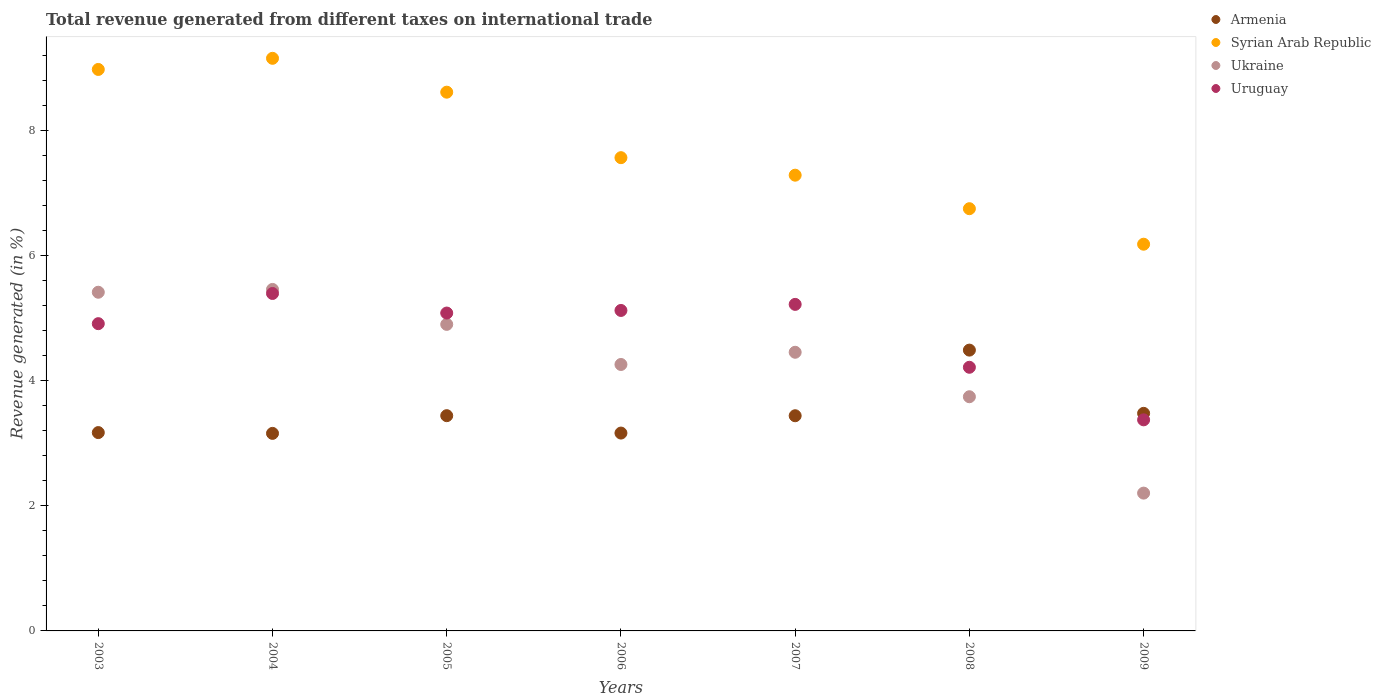How many different coloured dotlines are there?
Your answer should be very brief. 4. What is the total revenue generated in Armenia in 2008?
Your answer should be compact. 4.49. Across all years, what is the maximum total revenue generated in Uruguay?
Provide a short and direct response. 5.39. Across all years, what is the minimum total revenue generated in Syrian Arab Republic?
Ensure brevity in your answer.  6.18. What is the total total revenue generated in Ukraine in the graph?
Make the answer very short. 30.41. What is the difference between the total revenue generated in Armenia in 2003 and that in 2007?
Ensure brevity in your answer.  -0.27. What is the difference between the total revenue generated in Armenia in 2004 and the total revenue generated in Ukraine in 2009?
Keep it short and to the point. 0.95. What is the average total revenue generated in Ukraine per year?
Your response must be concise. 4.34. In the year 2003, what is the difference between the total revenue generated in Ukraine and total revenue generated in Syrian Arab Republic?
Provide a short and direct response. -3.56. In how many years, is the total revenue generated in Armenia greater than 4 %?
Provide a short and direct response. 1. What is the ratio of the total revenue generated in Ukraine in 2003 to that in 2006?
Provide a succinct answer. 1.27. What is the difference between the highest and the second highest total revenue generated in Ukraine?
Give a very brief answer. 0.04. What is the difference between the highest and the lowest total revenue generated in Ukraine?
Your response must be concise. 3.25. In how many years, is the total revenue generated in Syrian Arab Republic greater than the average total revenue generated in Syrian Arab Republic taken over all years?
Your response must be concise. 3. Is it the case that in every year, the sum of the total revenue generated in Uruguay and total revenue generated in Ukraine  is greater than the sum of total revenue generated in Syrian Arab Republic and total revenue generated in Armenia?
Give a very brief answer. No. How many years are there in the graph?
Give a very brief answer. 7. What is the difference between two consecutive major ticks on the Y-axis?
Ensure brevity in your answer.  2. Does the graph contain any zero values?
Offer a very short reply. No. How are the legend labels stacked?
Provide a short and direct response. Vertical. What is the title of the graph?
Your response must be concise. Total revenue generated from different taxes on international trade. What is the label or title of the Y-axis?
Keep it short and to the point. Revenue generated (in %). What is the Revenue generated (in %) in Armenia in 2003?
Offer a terse response. 3.17. What is the Revenue generated (in %) in Syrian Arab Republic in 2003?
Your answer should be very brief. 8.97. What is the Revenue generated (in %) in Ukraine in 2003?
Provide a succinct answer. 5.41. What is the Revenue generated (in %) of Uruguay in 2003?
Ensure brevity in your answer.  4.91. What is the Revenue generated (in %) of Armenia in 2004?
Make the answer very short. 3.16. What is the Revenue generated (in %) of Syrian Arab Republic in 2004?
Your answer should be very brief. 9.15. What is the Revenue generated (in %) in Ukraine in 2004?
Give a very brief answer. 5.46. What is the Revenue generated (in %) of Uruguay in 2004?
Ensure brevity in your answer.  5.39. What is the Revenue generated (in %) in Armenia in 2005?
Provide a succinct answer. 3.44. What is the Revenue generated (in %) of Syrian Arab Republic in 2005?
Keep it short and to the point. 8.61. What is the Revenue generated (in %) of Ukraine in 2005?
Make the answer very short. 4.9. What is the Revenue generated (in %) in Uruguay in 2005?
Make the answer very short. 5.08. What is the Revenue generated (in %) in Armenia in 2006?
Offer a terse response. 3.16. What is the Revenue generated (in %) of Syrian Arab Republic in 2006?
Your response must be concise. 7.56. What is the Revenue generated (in %) in Ukraine in 2006?
Give a very brief answer. 4.26. What is the Revenue generated (in %) of Uruguay in 2006?
Your answer should be compact. 5.12. What is the Revenue generated (in %) of Armenia in 2007?
Provide a short and direct response. 3.44. What is the Revenue generated (in %) in Syrian Arab Republic in 2007?
Offer a very short reply. 7.28. What is the Revenue generated (in %) of Ukraine in 2007?
Your answer should be compact. 4.45. What is the Revenue generated (in %) in Uruguay in 2007?
Your response must be concise. 5.22. What is the Revenue generated (in %) in Armenia in 2008?
Ensure brevity in your answer.  4.49. What is the Revenue generated (in %) of Syrian Arab Republic in 2008?
Offer a very short reply. 6.75. What is the Revenue generated (in %) of Ukraine in 2008?
Your answer should be very brief. 3.74. What is the Revenue generated (in %) of Uruguay in 2008?
Your answer should be compact. 4.21. What is the Revenue generated (in %) in Armenia in 2009?
Provide a short and direct response. 3.48. What is the Revenue generated (in %) in Syrian Arab Republic in 2009?
Ensure brevity in your answer.  6.18. What is the Revenue generated (in %) of Ukraine in 2009?
Keep it short and to the point. 2.2. What is the Revenue generated (in %) of Uruguay in 2009?
Your answer should be very brief. 3.37. Across all years, what is the maximum Revenue generated (in %) of Armenia?
Provide a short and direct response. 4.49. Across all years, what is the maximum Revenue generated (in %) of Syrian Arab Republic?
Ensure brevity in your answer.  9.15. Across all years, what is the maximum Revenue generated (in %) in Ukraine?
Keep it short and to the point. 5.46. Across all years, what is the maximum Revenue generated (in %) of Uruguay?
Provide a succinct answer. 5.39. Across all years, what is the minimum Revenue generated (in %) in Armenia?
Ensure brevity in your answer.  3.16. Across all years, what is the minimum Revenue generated (in %) of Syrian Arab Republic?
Give a very brief answer. 6.18. Across all years, what is the minimum Revenue generated (in %) in Ukraine?
Ensure brevity in your answer.  2.2. Across all years, what is the minimum Revenue generated (in %) in Uruguay?
Your answer should be very brief. 3.37. What is the total Revenue generated (in %) of Armenia in the graph?
Provide a succinct answer. 24.32. What is the total Revenue generated (in %) of Syrian Arab Republic in the graph?
Offer a terse response. 54.49. What is the total Revenue generated (in %) in Ukraine in the graph?
Provide a short and direct response. 30.41. What is the total Revenue generated (in %) of Uruguay in the graph?
Make the answer very short. 33.3. What is the difference between the Revenue generated (in %) of Armenia in 2003 and that in 2004?
Your response must be concise. 0.01. What is the difference between the Revenue generated (in %) in Syrian Arab Republic in 2003 and that in 2004?
Give a very brief answer. -0.18. What is the difference between the Revenue generated (in %) in Ukraine in 2003 and that in 2004?
Offer a very short reply. -0.04. What is the difference between the Revenue generated (in %) of Uruguay in 2003 and that in 2004?
Your answer should be compact. -0.48. What is the difference between the Revenue generated (in %) in Armenia in 2003 and that in 2005?
Your response must be concise. -0.27. What is the difference between the Revenue generated (in %) of Syrian Arab Republic in 2003 and that in 2005?
Your answer should be very brief. 0.36. What is the difference between the Revenue generated (in %) in Ukraine in 2003 and that in 2005?
Your answer should be compact. 0.51. What is the difference between the Revenue generated (in %) of Uruguay in 2003 and that in 2005?
Provide a succinct answer. -0.17. What is the difference between the Revenue generated (in %) of Armenia in 2003 and that in 2006?
Provide a short and direct response. 0.01. What is the difference between the Revenue generated (in %) in Syrian Arab Republic in 2003 and that in 2006?
Offer a very short reply. 1.41. What is the difference between the Revenue generated (in %) in Ukraine in 2003 and that in 2006?
Make the answer very short. 1.15. What is the difference between the Revenue generated (in %) of Uruguay in 2003 and that in 2006?
Ensure brevity in your answer.  -0.21. What is the difference between the Revenue generated (in %) in Armenia in 2003 and that in 2007?
Your answer should be very brief. -0.27. What is the difference between the Revenue generated (in %) in Syrian Arab Republic in 2003 and that in 2007?
Provide a succinct answer. 1.69. What is the difference between the Revenue generated (in %) in Uruguay in 2003 and that in 2007?
Your response must be concise. -0.31. What is the difference between the Revenue generated (in %) of Armenia in 2003 and that in 2008?
Give a very brief answer. -1.32. What is the difference between the Revenue generated (in %) of Syrian Arab Republic in 2003 and that in 2008?
Offer a terse response. 2.22. What is the difference between the Revenue generated (in %) of Ukraine in 2003 and that in 2008?
Ensure brevity in your answer.  1.67. What is the difference between the Revenue generated (in %) in Uruguay in 2003 and that in 2008?
Provide a succinct answer. 0.7. What is the difference between the Revenue generated (in %) in Armenia in 2003 and that in 2009?
Offer a terse response. -0.31. What is the difference between the Revenue generated (in %) of Syrian Arab Republic in 2003 and that in 2009?
Provide a short and direct response. 2.79. What is the difference between the Revenue generated (in %) of Ukraine in 2003 and that in 2009?
Your answer should be very brief. 3.21. What is the difference between the Revenue generated (in %) of Uruguay in 2003 and that in 2009?
Give a very brief answer. 1.54. What is the difference between the Revenue generated (in %) in Armenia in 2004 and that in 2005?
Your response must be concise. -0.28. What is the difference between the Revenue generated (in %) in Syrian Arab Republic in 2004 and that in 2005?
Your answer should be compact. 0.54. What is the difference between the Revenue generated (in %) in Ukraine in 2004 and that in 2005?
Offer a very short reply. 0.56. What is the difference between the Revenue generated (in %) in Uruguay in 2004 and that in 2005?
Provide a succinct answer. 0.31. What is the difference between the Revenue generated (in %) in Armenia in 2004 and that in 2006?
Your response must be concise. -0.01. What is the difference between the Revenue generated (in %) in Syrian Arab Republic in 2004 and that in 2006?
Offer a very short reply. 1.59. What is the difference between the Revenue generated (in %) in Ukraine in 2004 and that in 2006?
Keep it short and to the point. 1.2. What is the difference between the Revenue generated (in %) of Uruguay in 2004 and that in 2006?
Keep it short and to the point. 0.27. What is the difference between the Revenue generated (in %) of Armenia in 2004 and that in 2007?
Make the answer very short. -0.28. What is the difference between the Revenue generated (in %) in Syrian Arab Republic in 2004 and that in 2007?
Keep it short and to the point. 1.87. What is the difference between the Revenue generated (in %) in Uruguay in 2004 and that in 2007?
Give a very brief answer. 0.17. What is the difference between the Revenue generated (in %) in Armenia in 2004 and that in 2008?
Keep it short and to the point. -1.33. What is the difference between the Revenue generated (in %) in Syrian Arab Republic in 2004 and that in 2008?
Your answer should be very brief. 2.4. What is the difference between the Revenue generated (in %) in Ukraine in 2004 and that in 2008?
Your answer should be compact. 1.71. What is the difference between the Revenue generated (in %) of Uruguay in 2004 and that in 2008?
Your answer should be very brief. 1.18. What is the difference between the Revenue generated (in %) in Armenia in 2004 and that in 2009?
Give a very brief answer. -0.32. What is the difference between the Revenue generated (in %) in Syrian Arab Republic in 2004 and that in 2009?
Your answer should be compact. 2.97. What is the difference between the Revenue generated (in %) of Ukraine in 2004 and that in 2009?
Your response must be concise. 3.25. What is the difference between the Revenue generated (in %) of Uruguay in 2004 and that in 2009?
Make the answer very short. 2.02. What is the difference between the Revenue generated (in %) of Armenia in 2005 and that in 2006?
Your answer should be compact. 0.28. What is the difference between the Revenue generated (in %) in Syrian Arab Republic in 2005 and that in 2006?
Make the answer very short. 1.05. What is the difference between the Revenue generated (in %) of Ukraine in 2005 and that in 2006?
Provide a succinct answer. 0.64. What is the difference between the Revenue generated (in %) of Uruguay in 2005 and that in 2006?
Offer a very short reply. -0.04. What is the difference between the Revenue generated (in %) in Armenia in 2005 and that in 2007?
Offer a very short reply. 0. What is the difference between the Revenue generated (in %) in Syrian Arab Republic in 2005 and that in 2007?
Provide a succinct answer. 1.33. What is the difference between the Revenue generated (in %) in Ukraine in 2005 and that in 2007?
Provide a succinct answer. 0.45. What is the difference between the Revenue generated (in %) of Uruguay in 2005 and that in 2007?
Make the answer very short. -0.14. What is the difference between the Revenue generated (in %) in Armenia in 2005 and that in 2008?
Offer a very short reply. -1.05. What is the difference between the Revenue generated (in %) of Syrian Arab Republic in 2005 and that in 2008?
Your response must be concise. 1.86. What is the difference between the Revenue generated (in %) of Ukraine in 2005 and that in 2008?
Give a very brief answer. 1.16. What is the difference between the Revenue generated (in %) in Uruguay in 2005 and that in 2008?
Your answer should be compact. 0.87. What is the difference between the Revenue generated (in %) of Armenia in 2005 and that in 2009?
Give a very brief answer. -0.04. What is the difference between the Revenue generated (in %) in Syrian Arab Republic in 2005 and that in 2009?
Keep it short and to the point. 2.43. What is the difference between the Revenue generated (in %) of Ukraine in 2005 and that in 2009?
Ensure brevity in your answer.  2.7. What is the difference between the Revenue generated (in %) of Uruguay in 2005 and that in 2009?
Give a very brief answer. 1.71. What is the difference between the Revenue generated (in %) of Armenia in 2006 and that in 2007?
Your answer should be compact. -0.28. What is the difference between the Revenue generated (in %) in Syrian Arab Republic in 2006 and that in 2007?
Ensure brevity in your answer.  0.28. What is the difference between the Revenue generated (in %) of Ukraine in 2006 and that in 2007?
Provide a short and direct response. -0.2. What is the difference between the Revenue generated (in %) in Uruguay in 2006 and that in 2007?
Make the answer very short. -0.1. What is the difference between the Revenue generated (in %) in Armenia in 2006 and that in 2008?
Your answer should be compact. -1.33. What is the difference between the Revenue generated (in %) in Syrian Arab Republic in 2006 and that in 2008?
Provide a short and direct response. 0.82. What is the difference between the Revenue generated (in %) in Ukraine in 2006 and that in 2008?
Offer a very short reply. 0.52. What is the difference between the Revenue generated (in %) of Uruguay in 2006 and that in 2008?
Your answer should be very brief. 0.91. What is the difference between the Revenue generated (in %) in Armenia in 2006 and that in 2009?
Offer a terse response. -0.32. What is the difference between the Revenue generated (in %) in Syrian Arab Republic in 2006 and that in 2009?
Keep it short and to the point. 1.38. What is the difference between the Revenue generated (in %) in Ukraine in 2006 and that in 2009?
Give a very brief answer. 2.06. What is the difference between the Revenue generated (in %) of Uruguay in 2006 and that in 2009?
Ensure brevity in your answer.  1.75. What is the difference between the Revenue generated (in %) in Armenia in 2007 and that in 2008?
Your response must be concise. -1.05. What is the difference between the Revenue generated (in %) of Syrian Arab Republic in 2007 and that in 2008?
Your answer should be compact. 0.54. What is the difference between the Revenue generated (in %) in Ukraine in 2007 and that in 2008?
Your response must be concise. 0.71. What is the difference between the Revenue generated (in %) in Uruguay in 2007 and that in 2008?
Your answer should be compact. 1. What is the difference between the Revenue generated (in %) of Armenia in 2007 and that in 2009?
Keep it short and to the point. -0.04. What is the difference between the Revenue generated (in %) in Syrian Arab Republic in 2007 and that in 2009?
Give a very brief answer. 1.1. What is the difference between the Revenue generated (in %) in Ukraine in 2007 and that in 2009?
Offer a terse response. 2.25. What is the difference between the Revenue generated (in %) in Uruguay in 2007 and that in 2009?
Ensure brevity in your answer.  1.84. What is the difference between the Revenue generated (in %) in Armenia in 2008 and that in 2009?
Ensure brevity in your answer.  1.01. What is the difference between the Revenue generated (in %) in Syrian Arab Republic in 2008 and that in 2009?
Provide a short and direct response. 0.57. What is the difference between the Revenue generated (in %) in Ukraine in 2008 and that in 2009?
Your response must be concise. 1.54. What is the difference between the Revenue generated (in %) of Uruguay in 2008 and that in 2009?
Offer a very short reply. 0.84. What is the difference between the Revenue generated (in %) of Armenia in 2003 and the Revenue generated (in %) of Syrian Arab Republic in 2004?
Provide a succinct answer. -5.98. What is the difference between the Revenue generated (in %) of Armenia in 2003 and the Revenue generated (in %) of Ukraine in 2004?
Give a very brief answer. -2.29. What is the difference between the Revenue generated (in %) of Armenia in 2003 and the Revenue generated (in %) of Uruguay in 2004?
Make the answer very short. -2.22. What is the difference between the Revenue generated (in %) in Syrian Arab Republic in 2003 and the Revenue generated (in %) in Ukraine in 2004?
Offer a very short reply. 3.51. What is the difference between the Revenue generated (in %) of Syrian Arab Republic in 2003 and the Revenue generated (in %) of Uruguay in 2004?
Your response must be concise. 3.58. What is the difference between the Revenue generated (in %) of Ukraine in 2003 and the Revenue generated (in %) of Uruguay in 2004?
Your response must be concise. 0.02. What is the difference between the Revenue generated (in %) in Armenia in 2003 and the Revenue generated (in %) in Syrian Arab Republic in 2005?
Provide a short and direct response. -5.44. What is the difference between the Revenue generated (in %) of Armenia in 2003 and the Revenue generated (in %) of Ukraine in 2005?
Ensure brevity in your answer.  -1.73. What is the difference between the Revenue generated (in %) in Armenia in 2003 and the Revenue generated (in %) in Uruguay in 2005?
Offer a very short reply. -1.91. What is the difference between the Revenue generated (in %) of Syrian Arab Republic in 2003 and the Revenue generated (in %) of Ukraine in 2005?
Ensure brevity in your answer.  4.07. What is the difference between the Revenue generated (in %) of Syrian Arab Republic in 2003 and the Revenue generated (in %) of Uruguay in 2005?
Offer a very short reply. 3.89. What is the difference between the Revenue generated (in %) in Ukraine in 2003 and the Revenue generated (in %) in Uruguay in 2005?
Ensure brevity in your answer.  0.33. What is the difference between the Revenue generated (in %) of Armenia in 2003 and the Revenue generated (in %) of Syrian Arab Republic in 2006?
Provide a succinct answer. -4.39. What is the difference between the Revenue generated (in %) in Armenia in 2003 and the Revenue generated (in %) in Ukraine in 2006?
Ensure brevity in your answer.  -1.09. What is the difference between the Revenue generated (in %) in Armenia in 2003 and the Revenue generated (in %) in Uruguay in 2006?
Offer a very short reply. -1.95. What is the difference between the Revenue generated (in %) in Syrian Arab Republic in 2003 and the Revenue generated (in %) in Ukraine in 2006?
Make the answer very short. 4.71. What is the difference between the Revenue generated (in %) in Syrian Arab Republic in 2003 and the Revenue generated (in %) in Uruguay in 2006?
Make the answer very short. 3.85. What is the difference between the Revenue generated (in %) in Ukraine in 2003 and the Revenue generated (in %) in Uruguay in 2006?
Your answer should be compact. 0.29. What is the difference between the Revenue generated (in %) in Armenia in 2003 and the Revenue generated (in %) in Syrian Arab Republic in 2007?
Keep it short and to the point. -4.11. What is the difference between the Revenue generated (in %) in Armenia in 2003 and the Revenue generated (in %) in Ukraine in 2007?
Your response must be concise. -1.28. What is the difference between the Revenue generated (in %) in Armenia in 2003 and the Revenue generated (in %) in Uruguay in 2007?
Make the answer very short. -2.05. What is the difference between the Revenue generated (in %) in Syrian Arab Republic in 2003 and the Revenue generated (in %) in Ukraine in 2007?
Offer a very short reply. 4.52. What is the difference between the Revenue generated (in %) in Syrian Arab Republic in 2003 and the Revenue generated (in %) in Uruguay in 2007?
Offer a terse response. 3.75. What is the difference between the Revenue generated (in %) in Ukraine in 2003 and the Revenue generated (in %) in Uruguay in 2007?
Offer a terse response. 0.19. What is the difference between the Revenue generated (in %) in Armenia in 2003 and the Revenue generated (in %) in Syrian Arab Republic in 2008?
Make the answer very short. -3.58. What is the difference between the Revenue generated (in %) of Armenia in 2003 and the Revenue generated (in %) of Ukraine in 2008?
Ensure brevity in your answer.  -0.57. What is the difference between the Revenue generated (in %) in Armenia in 2003 and the Revenue generated (in %) in Uruguay in 2008?
Ensure brevity in your answer.  -1.04. What is the difference between the Revenue generated (in %) of Syrian Arab Republic in 2003 and the Revenue generated (in %) of Ukraine in 2008?
Your response must be concise. 5.23. What is the difference between the Revenue generated (in %) of Syrian Arab Republic in 2003 and the Revenue generated (in %) of Uruguay in 2008?
Offer a terse response. 4.76. What is the difference between the Revenue generated (in %) of Ukraine in 2003 and the Revenue generated (in %) of Uruguay in 2008?
Provide a short and direct response. 1.2. What is the difference between the Revenue generated (in %) in Armenia in 2003 and the Revenue generated (in %) in Syrian Arab Republic in 2009?
Give a very brief answer. -3.01. What is the difference between the Revenue generated (in %) in Armenia in 2003 and the Revenue generated (in %) in Uruguay in 2009?
Ensure brevity in your answer.  -0.2. What is the difference between the Revenue generated (in %) in Syrian Arab Republic in 2003 and the Revenue generated (in %) in Ukraine in 2009?
Your response must be concise. 6.77. What is the difference between the Revenue generated (in %) in Syrian Arab Republic in 2003 and the Revenue generated (in %) in Uruguay in 2009?
Ensure brevity in your answer.  5.6. What is the difference between the Revenue generated (in %) in Ukraine in 2003 and the Revenue generated (in %) in Uruguay in 2009?
Make the answer very short. 2.04. What is the difference between the Revenue generated (in %) of Armenia in 2004 and the Revenue generated (in %) of Syrian Arab Republic in 2005?
Your response must be concise. -5.45. What is the difference between the Revenue generated (in %) in Armenia in 2004 and the Revenue generated (in %) in Ukraine in 2005?
Make the answer very short. -1.74. What is the difference between the Revenue generated (in %) in Armenia in 2004 and the Revenue generated (in %) in Uruguay in 2005?
Ensure brevity in your answer.  -1.92. What is the difference between the Revenue generated (in %) in Syrian Arab Republic in 2004 and the Revenue generated (in %) in Ukraine in 2005?
Provide a short and direct response. 4.25. What is the difference between the Revenue generated (in %) in Syrian Arab Republic in 2004 and the Revenue generated (in %) in Uruguay in 2005?
Your answer should be very brief. 4.07. What is the difference between the Revenue generated (in %) in Ukraine in 2004 and the Revenue generated (in %) in Uruguay in 2005?
Make the answer very short. 0.38. What is the difference between the Revenue generated (in %) of Armenia in 2004 and the Revenue generated (in %) of Syrian Arab Republic in 2006?
Your answer should be very brief. -4.4. What is the difference between the Revenue generated (in %) in Armenia in 2004 and the Revenue generated (in %) in Ukraine in 2006?
Offer a terse response. -1.1. What is the difference between the Revenue generated (in %) in Armenia in 2004 and the Revenue generated (in %) in Uruguay in 2006?
Provide a succinct answer. -1.96. What is the difference between the Revenue generated (in %) of Syrian Arab Republic in 2004 and the Revenue generated (in %) of Ukraine in 2006?
Your answer should be compact. 4.89. What is the difference between the Revenue generated (in %) in Syrian Arab Republic in 2004 and the Revenue generated (in %) in Uruguay in 2006?
Your answer should be compact. 4.03. What is the difference between the Revenue generated (in %) of Ukraine in 2004 and the Revenue generated (in %) of Uruguay in 2006?
Your answer should be compact. 0.34. What is the difference between the Revenue generated (in %) in Armenia in 2004 and the Revenue generated (in %) in Syrian Arab Republic in 2007?
Provide a short and direct response. -4.12. What is the difference between the Revenue generated (in %) of Armenia in 2004 and the Revenue generated (in %) of Ukraine in 2007?
Provide a succinct answer. -1.3. What is the difference between the Revenue generated (in %) of Armenia in 2004 and the Revenue generated (in %) of Uruguay in 2007?
Provide a short and direct response. -2.06. What is the difference between the Revenue generated (in %) in Syrian Arab Republic in 2004 and the Revenue generated (in %) in Ukraine in 2007?
Make the answer very short. 4.7. What is the difference between the Revenue generated (in %) in Syrian Arab Republic in 2004 and the Revenue generated (in %) in Uruguay in 2007?
Provide a short and direct response. 3.93. What is the difference between the Revenue generated (in %) of Ukraine in 2004 and the Revenue generated (in %) of Uruguay in 2007?
Make the answer very short. 0.24. What is the difference between the Revenue generated (in %) in Armenia in 2004 and the Revenue generated (in %) in Syrian Arab Republic in 2008?
Provide a succinct answer. -3.59. What is the difference between the Revenue generated (in %) of Armenia in 2004 and the Revenue generated (in %) of Ukraine in 2008?
Offer a terse response. -0.59. What is the difference between the Revenue generated (in %) of Armenia in 2004 and the Revenue generated (in %) of Uruguay in 2008?
Provide a short and direct response. -1.06. What is the difference between the Revenue generated (in %) in Syrian Arab Republic in 2004 and the Revenue generated (in %) in Ukraine in 2008?
Provide a succinct answer. 5.41. What is the difference between the Revenue generated (in %) in Syrian Arab Republic in 2004 and the Revenue generated (in %) in Uruguay in 2008?
Ensure brevity in your answer.  4.94. What is the difference between the Revenue generated (in %) of Ukraine in 2004 and the Revenue generated (in %) of Uruguay in 2008?
Ensure brevity in your answer.  1.24. What is the difference between the Revenue generated (in %) in Armenia in 2004 and the Revenue generated (in %) in Syrian Arab Republic in 2009?
Provide a short and direct response. -3.02. What is the difference between the Revenue generated (in %) in Armenia in 2004 and the Revenue generated (in %) in Ukraine in 2009?
Make the answer very short. 0.95. What is the difference between the Revenue generated (in %) in Armenia in 2004 and the Revenue generated (in %) in Uruguay in 2009?
Offer a very short reply. -0.22. What is the difference between the Revenue generated (in %) in Syrian Arab Republic in 2004 and the Revenue generated (in %) in Ukraine in 2009?
Provide a succinct answer. 6.95. What is the difference between the Revenue generated (in %) of Syrian Arab Republic in 2004 and the Revenue generated (in %) of Uruguay in 2009?
Make the answer very short. 5.78. What is the difference between the Revenue generated (in %) in Ukraine in 2004 and the Revenue generated (in %) in Uruguay in 2009?
Your answer should be compact. 2.08. What is the difference between the Revenue generated (in %) of Armenia in 2005 and the Revenue generated (in %) of Syrian Arab Republic in 2006?
Offer a terse response. -4.12. What is the difference between the Revenue generated (in %) of Armenia in 2005 and the Revenue generated (in %) of Ukraine in 2006?
Make the answer very short. -0.82. What is the difference between the Revenue generated (in %) in Armenia in 2005 and the Revenue generated (in %) in Uruguay in 2006?
Offer a very short reply. -1.68. What is the difference between the Revenue generated (in %) of Syrian Arab Republic in 2005 and the Revenue generated (in %) of Ukraine in 2006?
Your answer should be compact. 4.35. What is the difference between the Revenue generated (in %) of Syrian Arab Republic in 2005 and the Revenue generated (in %) of Uruguay in 2006?
Provide a succinct answer. 3.49. What is the difference between the Revenue generated (in %) in Ukraine in 2005 and the Revenue generated (in %) in Uruguay in 2006?
Offer a terse response. -0.22. What is the difference between the Revenue generated (in %) in Armenia in 2005 and the Revenue generated (in %) in Syrian Arab Republic in 2007?
Keep it short and to the point. -3.84. What is the difference between the Revenue generated (in %) in Armenia in 2005 and the Revenue generated (in %) in Ukraine in 2007?
Offer a very short reply. -1.01. What is the difference between the Revenue generated (in %) of Armenia in 2005 and the Revenue generated (in %) of Uruguay in 2007?
Give a very brief answer. -1.78. What is the difference between the Revenue generated (in %) in Syrian Arab Republic in 2005 and the Revenue generated (in %) in Ukraine in 2007?
Provide a succinct answer. 4.15. What is the difference between the Revenue generated (in %) of Syrian Arab Republic in 2005 and the Revenue generated (in %) of Uruguay in 2007?
Give a very brief answer. 3.39. What is the difference between the Revenue generated (in %) in Ukraine in 2005 and the Revenue generated (in %) in Uruguay in 2007?
Your answer should be very brief. -0.32. What is the difference between the Revenue generated (in %) of Armenia in 2005 and the Revenue generated (in %) of Syrian Arab Republic in 2008?
Keep it short and to the point. -3.31. What is the difference between the Revenue generated (in %) of Armenia in 2005 and the Revenue generated (in %) of Ukraine in 2008?
Ensure brevity in your answer.  -0.3. What is the difference between the Revenue generated (in %) in Armenia in 2005 and the Revenue generated (in %) in Uruguay in 2008?
Your answer should be very brief. -0.77. What is the difference between the Revenue generated (in %) in Syrian Arab Republic in 2005 and the Revenue generated (in %) in Ukraine in 2008?
Your answer should be very brief. 4.87. What is the difference between the Revenue generated (in %) of Syrian Arab Republic in 2005 and the Revenue generated (in %) of Uruguay in 2008?
Ensure brevity in your answer.  4.39. What is the difference between the Revenue generated (in %) of Ukraine in 2005 and the Revenue generated (in %) of Uruguay in 2008?
Ensure brevity in your answer.  0.69. What is the difference between the Revenue generated (in %) in Armenia in 2005 and the Revenue generated (in %) in Syrian Arab Republic in 2009?
Your answer should be compact. -2.74. What is the difference between the Revenue generated (in %) in Armenia in 2005 and the Revenue generated (in %) in Ukraine in 2009?
Offer a very short reply. 1.24. What is the difference between the Revenue generated (in %) of Armenia in 2005 and the Revenue generated (in %) of Uruguay in 2009?
Offer a terse response. 0.07. What is the difference between the Revenue generated (in %) of Syrian Arab Republic in 2005 and the Revenue generated (in %) of Ukraine in 2009?
Your response must be concise. 6.41. What is the difference between the Revenue generated (in %) of Syrian Arab Republic in 2005 and the Revenue generated (in %) of Uruguay in 2009?
Provide a succinct answer. 5.23. What is the difference between the Revenue generated (in %) of Ukraine in 2005 and the Revenue generated (in %) of Uruguay in 2009?
Provide a succinct answer. 1.53. What is the difference between the Revenue generated (in %) in Armenia in 2006 and the Revenue generated (in %) in Syrian Arab Republic in 2007?
Your response must be concise. -4.12. What is the difference between the Revenue generated (in %) of Armenia in 2006 and the Revenue generated (in %) of Ukraine in 2007?
Keep it short and to the point. -1.29. What is the difference between the Revenue generated (in %) of Armenia in 2006 and the Revenue generated (in %) of Uruguay in 2007?
Offer a terse response. -2.06. What is the difference between the Revenue generated (in %) in Syrian Arab Republic in 2006 and the Revenue generated (in %) in Ukraine in 2007?
Offer a terse response. 3.11. What is the difference between the Revenue generated (in %) in Syrian Arab Republic in 2006 and the Revenue generated (in %) in Uruguay in 2007?
Give a very brief answer. 2.34. What is the difference between the Revenue generated (in %) of Ukraine in 2006 and the Revenue generated (in %) of Uruguay in 2007?
Give a very brief answer. -0.96. What is the difference between the Revenue generated (in %) of Armenia in 2006 and the Revenue generated (in %) of Syrian Arab Republic in 2008?
Provide a succinct answer. -3.58. What is the difference between the Revenue generated (in %) in Armenia in 2006 and the Revenue generated (in %) in Ukraine in 2008?
Keep it short and to the point. -0.58. What is the difference between the Revenue generated (in %) in Armenia in 2006 and the Revenue generated (in %) in Uruguay in 2008?
Your answer should be very brief. -1.05. What is the difference between the Revenue generated (in %) in Syrian Arab Republic in 2006 and the Revenue generated (in %) in Ukraine in 2008?
Make the answer very short. 3.82. What is the difference between the Revenue generated (in %) of Syrian Arab Republic in 2006 and the Revenue generated (in %) of Uruguay in 2008?
Your response must be concise. 3.35. What is the difference between the Revenue generated (in %) in Ukraine in 2006 and the Revenue generated (in %) in Uruguay in 2008?
Make the answer very short. 0.04. What is the difference between the Revenue generated (in %) of Armenia in 2006 and the Revenue generated (in %) of Syrian Arab Republic in 2009?
Offer a very short reply. -3.02. What is the difference between the Revenue generated (in %) in Armenia in 2006 and the Revenue generated (in %) in Ukraine in 2009?
Make the answer very short. 0.96. What is the difference between the Revenue generated (in %) in Armenia in 2006 and the Revenue generated (in %) in Uruguay in 2009?
Offer a terse response. -0.21. What is the difference between the Revenue generated (in %) in Syrian Arab Republic in 2006 and the Revenue generated (in %) in Ukraine in 2009?
Offer a very short reply. 5.36. What is the difference between the Revenue generated (in %) of Syrian Arab Republic in 2006 and the Revenue generated (in %) of Uruguay in 2009?
Provide a short and direct response. 4.19. What is the difference between the Revenue generated (in %) of Ukraine in 2006 and the Revenue generated (in %) of Uruguay in 2009?
Offer a very short reply. 0.88. What is the difference between the Revenue generated (in %) in Armenia in 2007 and the Revenue generated (in %) in Syrian Arab Republic in 2008?
Make the answer very short. -3.31. What is the difference between the Revenue generated (in %) in Armenia in 2007 and the Revenue generated (in %) in Ukraine in 2008?
Provide a succinct answer. -0.3. What is the difference between the Revenue generated (in %) in Armenia in 2007 and the Revenue generated (in %) in Uruguay in 2008?
Offer a terse response. -0.77. What is the difference between the Revenue generated (in %) in Syrian Arab Republic in 2007 and the Revenue generated (in %) in Ukraine in 2008?
Offer a very short reply. 3.54. What is the difference between the Revenue generated (in %) in Syrian Arab Republic in 2007 and the Revenue generated (in %) in Uruguay in 2008?
Ensure brevity in your answer.  3.07. What is the difference between the Revenue generated (in %) of Ukraine in 2007 and the Revenue generated (in %) of Uruguay in 2008?
Provide a succinct answer. 0.24. What is the difference between the Revenue generated (in %) of Armenia in 2007 and the Revenue generated (in %) of Syrian Arab Republic in 2009?
Keep it short and to the point. -2.74. What is the difference between the Revenue generated (in %) of Armenia in 2007 and the Revenue generated (in %) of Ukraine in 2009?
Provide a succinct answer. 1.24. What is the difference between the Revenue generated (in %) in Armenia in 2007 and the Revenue generated (in %) in Uruguay in 2009?
Offer a very short reply. 0.07. What is the difference between the Revenue generated (in %) of Syrian Arab Republic in 2007 and the Revenue generated (in %) of Ukraine in 2009?
Keep it short and to the point. 5.08. What is the difference between the Revenue generated (in %) in Syrian Arab Republic in 2007 and the Revenue generated (in %) in Uruguay in 2009?
Provide a succinct answer. 3.91. What is the difference between the Revenue generated (in %) of Ukraine in 2007 and the Revenue generated (in %) of Uruguay in 2009?
Your answer should be very brief. 1.08. What is the difference between the Revenue generated (in %) of Armenia in 2008 and the Revenue generated (in %) of Syrian Arab Republic in 2009?
Make the answer very short. -1.69. What is the difference between the Revenue generated (in %) of Armenia in 2008 and the Revenue generated (in %) of Ukraine in 2009?
Offer a very short reply. 2.28. What is the difference between the Revenue generated (in %) in Armenia in 2008 and the Revenue generated (in %) in Uruguay in 2009?
Make the answer very short. 1.11. What is the difference between the Revenue generated (in %) of Syrian Arab Republic in 2008 and the Revenue generated (in %) of Ukraine in 2009?
Offer a terse response. 4.54. What is the difference between the Revenue generated (in %) of Syrian Arab Republic in 2008 and the Revenue generated (in %) of Uruguay in 2009?
Provide a short and direct response. 3.37. What is the difference between the Revenue generated (in %) in Ukraine in 2008 and the Revenue generated (in %) in Uruguay in 2009?
Offer a very short reply. 0.37. What is the average Revenue generated (in %) of Armenia per year?
Your answer should be compact. 3.47. What is the average Revenue generated (in %) of Syrian Arab Republic per year?
Your answer should be compact. 7.78. What is the average Revenue generated (in %) in Ukraine per year?
Your answer should be compact. 4.34. What is the average Revenue generated (in %) in Uruguay per year?
Provide a short and direct response. 4.76. In the year 2003, what is the difference between the Revenue generated (in %) in Armenia and Revenue generated (in %) in Syrian Arab Republic?
Provide a succinct answer. -5.8. In the year 2003, what is the difference between the Revenue generated (in %) of Armenia and Revenue generated (in %) of Ukraine?
Your response must be concise. -2.24. In the year 2003, what is the difference between the Revenue generated (in %) of Armenia and Revenue generated (in %) of Uruguay?
Your answer should be very brief. -1.74. In the year 2003, what is the difference between the Revenue generated (in %) in Syrian Arab Republic and Revenue generated (in %) in Ukraine?
Your response must be concise. 3.56. In the year 2003, what is the difference between the Revenue generated (in %) in Syrian Arab Republic and Revenue generated (in %) in Uruguay?
Your answer should be compact. 4.06. In the year 2003, what is the difference between the Revenue generated (in %) in Ukraine and Revenue generated (in %) in Uruguay?
Offer a very short reply. 0.5. In the year 2004, what is the difference between the Revenue generated (in %) in Armenia and Revenue generated (in %) in Syrian Arab Republic?
Your answer should be compact. -5.99. In the year 2004, what is the difference between the Revenue generated (in %) of Armenia and Revenue generated (in %) of Ukraine?
Keep it short and to the point. -2.3. In the year 2004, what is the difference between the Revenue generated (in %) of Armenia and Revenue generated (in %) of Uruguay?
Ensure brevity in your answer.  -2.23. In the year 2004, what is the difference between the Revenue generated (in %) in Syrian Arab Republic and Revenue generated (in %) in Ukraine?
Your answer should be very brief. 3.69. In the year 2004, what is the difference between the Revenue generated (in %) of Syrian Arab Republic and Revenue generated (in %) of Uruguay?
Offer a terse response. 3.76. In the year 2004, what is the difference between the Revenue generated (in %) in Ukraine and Revenue generated (in %) in Uruguay?
Your answer should be very brief. 0.06. In the year 2005, what is the difference between the Revenue generated (in %) of Armenia and Revenue generated (in %) of Syrian Arab Republic?
Your answer should be very brief. -5.17. In the year 2005, what is the difference between the Revenue generated (in %) of Armenia and Revenue generated (in %) of Ukraine?
Your response must be concise. -1.46. In the year 2005, what is the difference between the Revenue generated (in %) of Armenia and Revenue generated (in %) of Uruguay?
Offer a terse response. -1.64. In the year 2005, what is the difference between the Revenue generated (in %) of Syrian Arab Republic and Revenue generated (in %) of Ukraine?
Your response must be concise. 3.71. In the year 2005, what is the difference between the Revenue generated (in %) in Syrian Arab Republic and Revenue generated (in %) in Uruguay?
Give a very brief answer. 3.53. In the year 2005, what is the difference between the Revenue generated (in %) in Ukraine and Revenue generated (in %) in Uruguay?
Provide a short and direct response. -0.18. In the year 2006, what is the difference between the Revenue generated (in %) in Armenia and Revenue generated (in %) in Syrian Arab Republic?
Ensure brevity in your answer.  -4.4. In the year 2006, what is the difference between the Revenue generated (in %) of Armenia and Revenue generated (in %) of Ukraine?
Provide a short and direct response. -1.1. In the year 2006, what is the difference between the Revenue generated (in %) in Armenia and Revenue generated (in %) in Uruguay?
Your answer should be compact. -1.96. In the year 2006, what is the difference between the Revenue generated (in %) of Syrian Arab Republic and Revenue generated (in %) of Ukraine?
Ensure brevity in your answer.  3.3. In the year 2006, what is the difference between the Revenue generated (in %) of Syrian Arab Republic and Revenue generated (in %) of Uruguay?
Provide a succinct answer. 2.44. In the year 2006, what is the difference between the Revenue generated (in %) in Ukraine and Revenue generated (in %) in Uruguay?
Provide a succinct answer. -0.86. In the year 2007, what is the difference between the Revenue generated (in %) of Armenia and Revenue generated (in %) of Syrian Arab Republic?
Your answer should be very brief. -3.84. In the year 2007, what is the difference between the Revenue generated (in %) in Armenia and Revenue generated (in %) in Ukraine?
Provide a succinct answer. -1.01. In the year 2007, what is the difference between the Revenue generated (in %) of Armenia and Revenue generated (in %) of Uruguay?
Offer a very short reply. -1.78. In the year 2007, what is the difference between the Revenue generated (in %) of Syrian Arab Republic and Revenue generated (in %) of Ukraine?
Your answer should be compact. 2.83. In the year 2007, what is the difference between the Revenue generated (in %) of Syrian Arab Republic and Revenue generated (in %) of Uruguay?
Keep it short and to the point. 2.06. In the year 2007, what is the difference between the Revenue generated (in %) of Ukraine and Revenue generated (in %) of Uruguay?
Offer a very short reply. -0.77. In the year 2008, what is the difference between the Revenue generated (in %) of Armenia and Revenue generated (in %) of Syrian Arab Republic?
Provide a succinct answer. -2.26. In the year 2008, what is the difference between the Revenue generated (in %) of Armenia and Revenue generated (in %) of Ukraine?
Your answer should be compact. 0.74. In the year 2008, what is the difference between the Revenue generated (in %) in Armenia and Revenue generated (in %) in Uruguay?
Keep it short and to the point. 0.27. In the year 2008, what is the difference between the Revenue generated (in %) in Syrian Arab Republic and Revenue generated (in %) in Ukraine?
Give a very brief answer. 3. In the year 2008, what is the difference between the Revenue generated (in %) in Syrian Arab Republic and Revenue generated (in %) in Uruguay?
Make the answer very short. 2.53. In the year 2008, what is the difference between the Revenue generated (in %) in Ukraine and Revenue generated (in %) in Uruguay?
Ensure brevity in your answer.  -0.47. In the year 2009, what is the difference between the Revenue generated (in %) in Armenia and Revenue generated (in %) in Syrian Arab Republic?
Offer a very short reply. -2.7. In the year 2009, what is the difference between the Revenue generated (in %) of Armenia and Revenue generated (in %) of Ukraine?
Give a very brief answer. 1.27. In the year 2009, what is the difference between the Revenue generated (in %) in Armenia and Revenue generated (in %) in Uruguay?
Keep it short and to the point. 0.1. In the year 2009, what is the difference between the Revenue generated (in %) of Syrian Arab Republic and Revenue generated (in %) of Ukraine?
Your answer should be very brief. 3.98. In the year 2009, what is the difference between the Revenue generated (in %) of Syrian Arab Republic and Revenue generated (in %) of Uruguay?
Give a very brief answer. 2.81. In the year 2009, what is the difference between the Revenue generated (in %) of Ukraine and Revenue generated (in %) of Uruguay?
Your answer should be compact. -1.17. What is the ratio of the Revenue generated (in %) in Syrian Arab Republic in 2003 to that in 2004?
Your answer should be very brief. 0.98. What is the ratio of the Revenue generated (in %) in Uruguay in 2003 to that in 2004?
Offer a terse response. 0.91. What is the ratio of the Revenue generated (in %) in Armenia in 2003 to that in 2005?
Provide a succinct answer. 0.92. What is the ratio of the Revenue generated (in %) in Syrian Arab Republic in 2003 to that in 2005?
Offer a terse response. 1.04. What is the ratio of the Revenue generated (in %) of Ukraine in 2003 to that in 2005?
Offer a terse response. 1.1. What is the ratio of the Revenue generated (in %) of Uruguay in 2003 to that in 2005?
Your answer should be very brief. 0.97. What is the ratio of the Revenue generated (in %) of Armenia in 2003 to that in 2006?
Make the answer very short. 1. What is the ratio of the Revenue generated (in %) of Syrian Arab Republic in 2003 to that in 2006?
Make the answer very short. 1.19. What is the ratio of the Revenue generated (in %) of Ukraine in 2003 to that in 2006?
Your answer should be compact. 1.27. What is the ratio of the Revenue generated (in %) of Uruguay in 2003 to that in 2006?
Offer a very short reply. 0.96. What is the ratio of the Revenue generated (in %) in Armenia in 2003 to that in 2007?
Ensure brevity in your answer.  0.92. What is the ratio of the Revenue generated (in %) of Syrian Arab Republic in 2003 to that in 2007?
Your answer should be very brief. 1.23. What is the ratio of the Revenue generated (in %) of Ukraine in 2003 to that in 2007?
Your answer should be very brief. 1.22. What is the ratio of the Revenue generated (in %) of Uruguay in 2003 to that in 2007?
Ensure brevity in your answer.  0.94. What is the ratio of the Revenue generated (in %) in Armenia in 2003 to that in 2008?
Provide a short and direct response. 0.71. What is the ratio of the Revenue generated (in %) of Syrian Arab Republic in 2003 to that in 2008?
Give a very brief answer. 1.33. What is the ratio of the Revenue generated (in %) in Ukraine in 2003 to that in 2008?
Make the answer very short. 1.45. What is the ratio of the Revenue generated (in %) in Uruguay in 2003 to that in 2008?
Offer a very short reply. 1.17. What is the ratio of the Revenue generated (in %) of Armenia in 2003 to that in 2009?
Make the answer very short. 0.91. What is the ratio of the Revenue generated (in %) in Syrian Arab Republic in 2003 to that in 2009?
Ensure brevity in your answer.  1.45. What is the ratio of the Revenue generated (in %) in Ukraine in 2003 to that in 2009?
Keep it short and to the point. 2.46. What is the ratio of the Revenue generated (in %) of Uruguay in 2003 to that in 2009?
Ensure brevity in your answer.  1.46. What is the ratio of the Revenue generated (in %) in Armenia in 2004 to that in 2005?
Keep it short and to the point. 0.92. What is the ratio of the Revenue generated (in %) in Syrian Arab Republic in 2004 to that in 2005?
Provide a short and direct response. 1.06. What is the ratio of the Revenue generated (in %) of Ukraine in 2004 to that in 2005?
Offer a terse response. 1.11. What is the ratio of the Revenue generated (in %) in Uruguay in 2004 to that in 2005?
Your answer should be compact. 1.06. What is the ratio of the Revenue generated (in %) of Armenia in 2004 to that in 2006?
Provide a short and direct response. 1. What is the ratio of the Revenue generated (in %) of Syrian Arab Republic in 2004 to that in 2006?
Your answer should be very brief. 1.21. What is the ratio of the Revenue generated (in %) in Ukraine in 2004 to that in 2006?
Offer a terse response. 1.28. What is the ratio of the Revenue generated (in %) in Uruguay in 2004 to that in 2006?
Your answer should be very brief. 1.05. What is the ratio of the Revenue generated (in %) of Armenia in 2004 to that in 2007?
Offer a terse response. 0.92. What is the ratio of the Revenue generated (in %) of Syrian Arab Republic in 2004 to that in 2007?
Your response must be concise. 1.26. What is the ratio of the Revenue generated (in %) of Ukraine in 2004 to that in 2007?
Give a very brief answer. 1.23. What is the ratio of the Revenue generated (in %) of Uruguay in 2004 to that in 2007?
Your answer should be very brief. 1.03. What is the ratio of the Revenue generated (in %) of Armenia in 2004 to that in 2008?
Give a very brief answer. 0.7. What is the ratio of the Revenue generated (in %) in Syrian Arab Republic in 2004 to that in 2008?
Your answer should be compact. 1.36. What is the ratio of the Revenue generated (in %) of Ukraine in 2004 to that in 2008?
Ensure brevity in your answer.  1.46. What is the ratio of the Revenue generated (in %) in Uruguay in 2004 to that in 2008?
Provide a short and direct response. 1.28. What is the ratio of the Revenue generated (in %) of Armenia in 2004 to that in 2009?
Your answer should be compact. 0.91. What is the ratio of the Revenue generated (in %) of Syrian Arab Republic in 2004 to that in 2009?
Offer a terse response. 1.48. What is the ratio of the Revenue generated (in %) in Ukraine in 2004 to that in 2009?
Your answer should be very brief. 2.48. What is the ratio of the Revenue generated (in %) in Uruguay in 2004 to that in 2009?
Your answer should be very brief. 1.6. What is the ratio of the Revenue generated (in %) of Armenia in 2005 to that in 2006?
Your answer should be very brief. 1.09. What is the ratio of the Revenue generated (in %) of Syrian Arab Republic in 2005 to that in 2006?
Offer a terse response. 1.14. What is the ratio of the Revenue generated (in %) of Ukraine in 2005 to that in 2006?
Keep it short and to the point. 1.15. What is the ratio of the Revenue generated (in %) in Syrian Arab Republic in 2005 to that in 2007?
Provide a succinct answer. 1.18. What is the ratio of the Revenue generated (in %) of Ukraine in 2005 to that in 2007?
Your response must be concise. 1.1. What is the ratio of the Revenue generated (in %) in Uruguay in 2005 to that in 2007?
Offer a terse response. 0.97. What is the ratio of the Revenue generated (in %) of Armenia in 2005 to that in 2008?
Provide a short and direct response. 0.77. What is the ratio of the Revenue generated (in %) of Syrian Arab Republic in 2005 to that in 2008?
Your response must be concise. 1.28. What is the ratio of the Revenue generated (in %) of Ukraine in 2005 to that in 2008?
Your answer should be compact. 1.31. What is the ratio of the Revenue generated (in %) of Uruguay in 2005 to that in 2008?
Offer a very short reply. 1.21. What is the ratio of the Revenue generated (in %) in Armenia in 2005 to that in 2009?
Ensure brevity in your answer.  0.99. What is the ratio of the Revenue generated (in %) in Syrian Arab Republic in 2005 to that in 2009?
Ensure brevity in your answer.  1.39. What is the ratio of the Revenue generated (in %) of Ukraine in 2005 to that in 2009?
Provide a succinct answer. 2.22. What is the ratio of the Revenue generated (in %) in Uruguay in 2005 to that in 2009?
Give a very brief answer. 1.51. What is the ratio of the Revenue generated (in %) of Armenia in 2006 to that in 2007?
Give a very brief answer. 0.92. What is the ratio of the Revenue generated (in %) of Syrian Arab Republic in 2006 to that in 2007?
Your answer should be very brief. 1.04. What is the ratio of the Revenue generated (in %) in Ukraine in 2006 to that in 2007?
Your answer should be compact. 0.96. What is the ratio of the Revenue generated (in %) in Uruguay in 2006 to that in 2007?
Offer a very short reply. 0.98. What is the ratio of the Revenue generated (in %) in Armenia in 2006 to that in 2008?
Make the answer very short. 0.7. What is the ratio of the Revenue generated (in %) of Syrian Arab Republic in 2006 to that in 2008?
Offer a terse response. 1.12. What is the ratio of the Revenue generated (in %) of Ukraine in 2006 to that in 2008?
Provide a succinct answer. 1.14. What is the ratio of the Revenue generated (in %) of Uruguay in 2006 to that in 2008?
Your answer should be very brief. 1.22. What is the ratio of the Revenue generated (in %) of Armenia in 2006 to that in 2009?
Offer a very short reply. 0.91. What is the ratio of the Revenue generated (in %) in Syrian Arab Republic in 2006 to that in 2009?
Your response must be concise. 1.22. What is the ratio of the Revenue generated (in %) of Ukraine in 2006 to that in 2009?
Your answer should be compact. 1.93. What is the ratio of the Revenue generated (in %) of Uruguay in 2006 to that in 2009?
Make the answer very short. 1.52. What is the ratio of the Revenue generated (in %) of Armenia in 2007 to that in 2008?
Provide a succinct answer. 0.77. What is the ratio of the Revenue generated (in %) in Syrian Arab Republic in 2007 to that in 2008?
Offer a very short reply. 1.08. What is the ratio of the Revenue generated (in %) of Ukraine in 2007 to that in 2008?
Provide a short and direct response. 1.19. What is the ratio of the Revenue generated (in %) in Uruguay in 2007 to that in 2008?
Your answer should be very brief. 1.24. What is the ratio of the Revenue generated (in %) of Armenia in 2007 to that in 2009?
Provide a short and direct response. 0.99. What is the ratio of the Revenue generated (in %) in Syrian Arab Republic in 2007 to that in 2009?
Keep it short and to the point. 1.18. What is the ratio of the Revenue generated (in %) in Ukraine in 2007 to that in 2009?
Your answer should be very brief. 2.02. What is the ratio of the Revenue generated (in %) of Uruguay in 2007 to that in 2009?
Ensure brevity in your answer.  1.55. What is the ratio of the Revenue generated (in %) of Armenia in 2008 to that in 2009?
Give a very brief answer. 1.29. What is the ratio of the Revenue generated (in %) in Syrian Arab Republic in 2008 to that in 2009?
Ensure brevity in your answer.  1.09. What is the ratio of the Revenue generated (in %) of Ukraine in 2008 to that in 2009?
Offer a terse response. 1.7. What is the ratio of the Revenue generated (in %) of Uruguay in 2008 to that in 2009?
Your answer should be compact. 1.25. What is the difference between the highest and the second highest Revenue generated (in %) in Armenia?
Your response must be concise. 1.01. What is the difference between the highest and the second highest Revenue generated (in %) in Syrian Arab Republic?
Provide a short and direct response. 0.18. What is the difference between the highest and the second highest Revenue generated (in %) of Ukraine?
Give a very brief answer. 0.04. What is the difference between the highest and the second highest Revenue generated (in %) in Uruguay?
Keep it short and to the point. 0.17. What is the difference between the highest and the lowest Revenue generated (in %) of Armenia?
Ensure brevity in your answer.  1.33. What is the difference between the highest and the lowest Revenue generated (in %) in Syrian Arab Republic?
Your answer should be compact. 2.97. What is the difference between the highest and the lowest Revenue generated (in %) in Ukraine?
Keep it short and to the point. 3.25. What is the difference between the highest and the lowest Revenue generated (in %) of Uruguay?
Offer a very short reply. 2.02. 